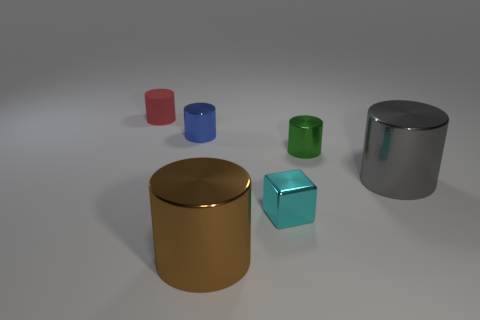Subtract all green blocks. Subtract all gray balls. How many blocks are left? 1 Subtract all yellow cylinders. How many blue blocks are left? 0 Add 5 large things. How many grays exist? 0 Subtract all big gray metallic objects. Subtract all tiny green metal cylinders. How many objects are left? 4 Add 6 large brown objects. How many large brown objects are left? 7 Add 3 large cyan metallic balls. How many large cyan metallic balls exist? 3 Add 4 large brown cylinders. How many objects exist? 10 Subtract all red cylinders. How many cylinders are left? 4 Subtract all metallic cylinders. How many cylinders are left? 1 Subtract 1 cyan blocks. How many objects are left? 5 